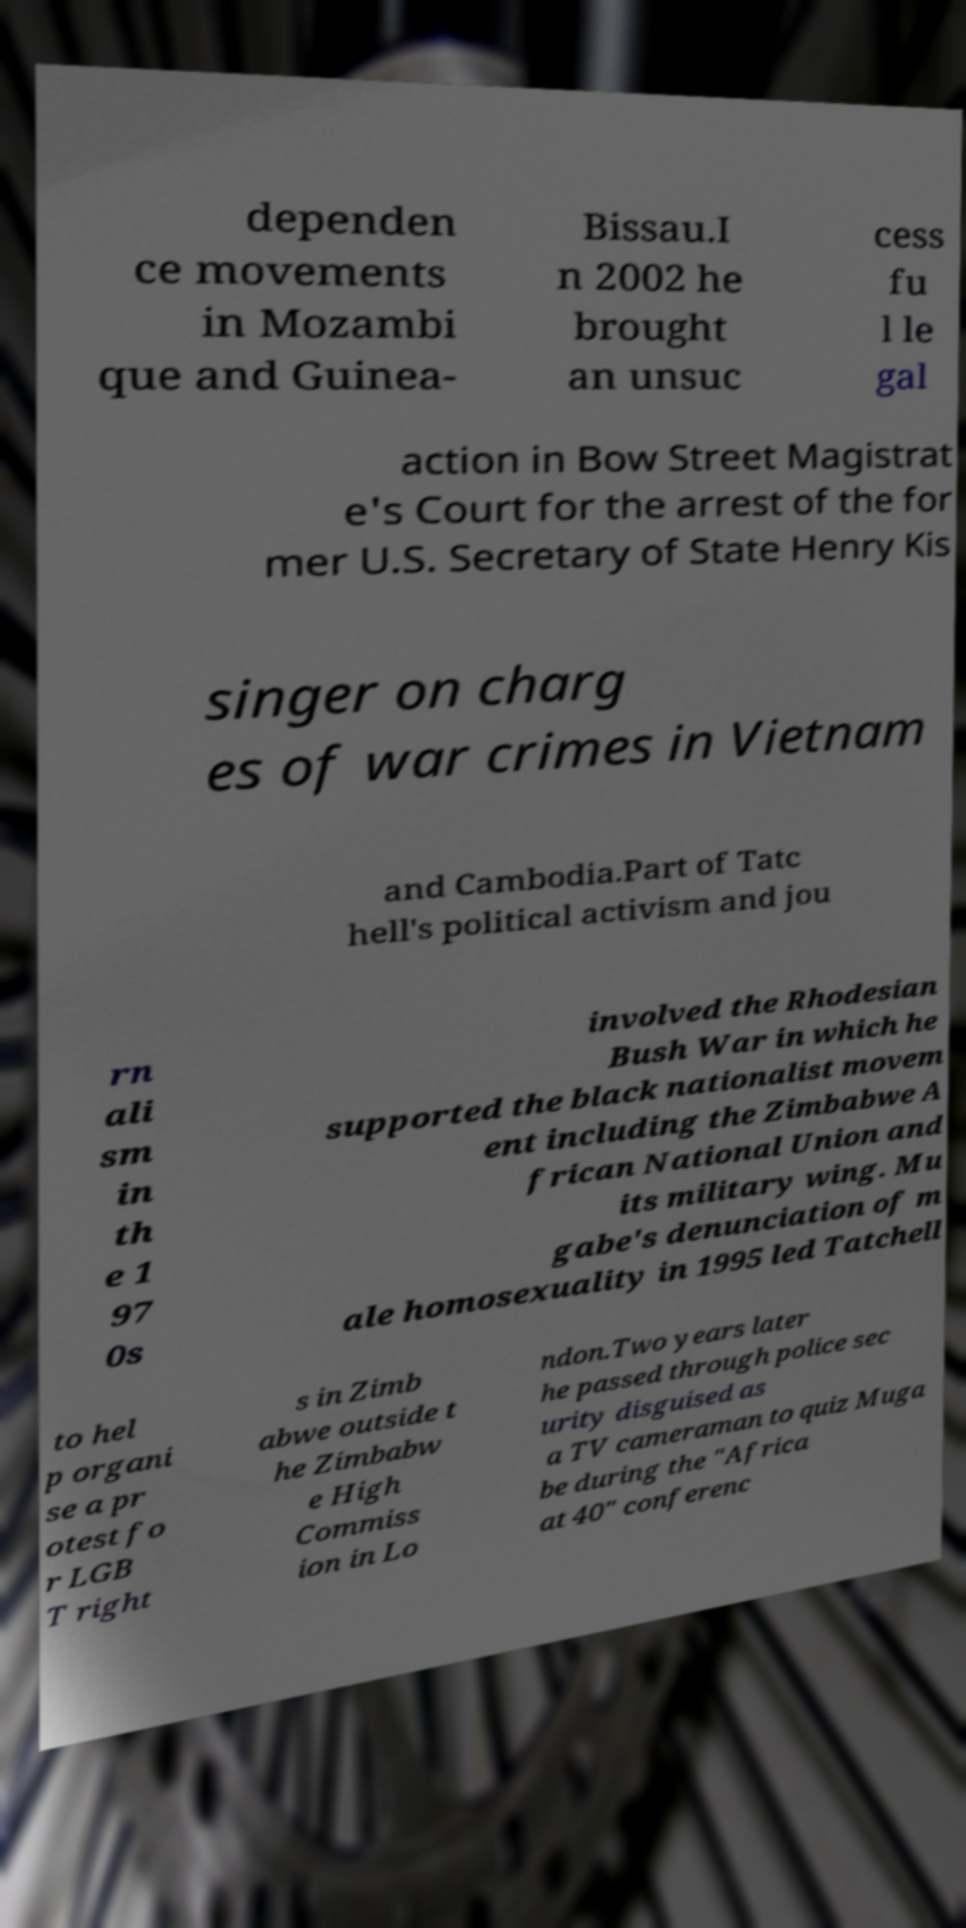What messages or text are displayed in this image? I need them in a readable, typed format. dependen ce movements in Mozambi que and Guinea- Bissau.I n 2002 he brought an unsuc cess fu l le gal action in Bow Street Magistrat e's Court for the arrest of the for mer U.S. Secretary of State Henry Kis singer on charg es of war crimes in Vietnam and Cambodia.Part of Tatc hell's political activism and jou rn ali sm in th e 1 97 0s involved the Rhodesian Bush War in which he supported the black nationalist movem ent including the Zimbabwe A frican National Union and its military wing. Mu gabe's denunciation of m ale homosexuality in 1995 led Tatchell to hel p organi se a pr otest fo r LGB T right s in Zimb abwe outside t he Zimbabw e High Commiss ion in Lo ndon.Two years later he passed through police sec urity disguised as a TV cameraman to quiz Muga be during the "Africa at 40" conferenc 